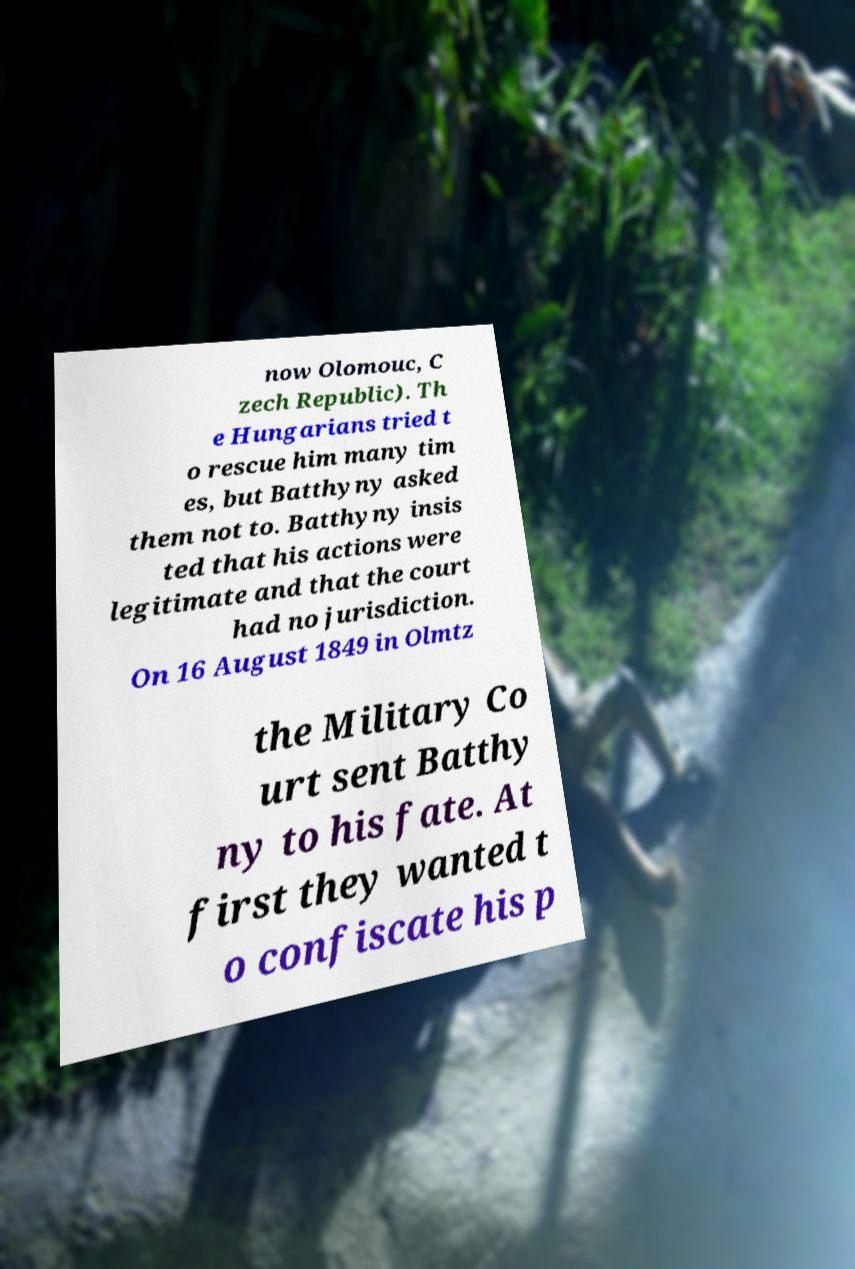Can you accurately transcribe the text from the provided image for me? now Olomouc, C zech Republic). Th e Hungarians tried t o rescue him many tim es, but Batthyny asked them not to. Batthyny insis ted that his actions were legitimate and that the court had no jurisdiction. On 16 August 1849 in Olmtz the Military Co urt sent Batthy ny to his fate. At first they wanted t o confiscate his p 